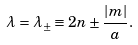<formula> <loc_0><loc_0><loc_500><loc_500>\lambda = \lambda _ { \pm } \equiv 2 n \pm \frac { | m | } { a } .</formula> 